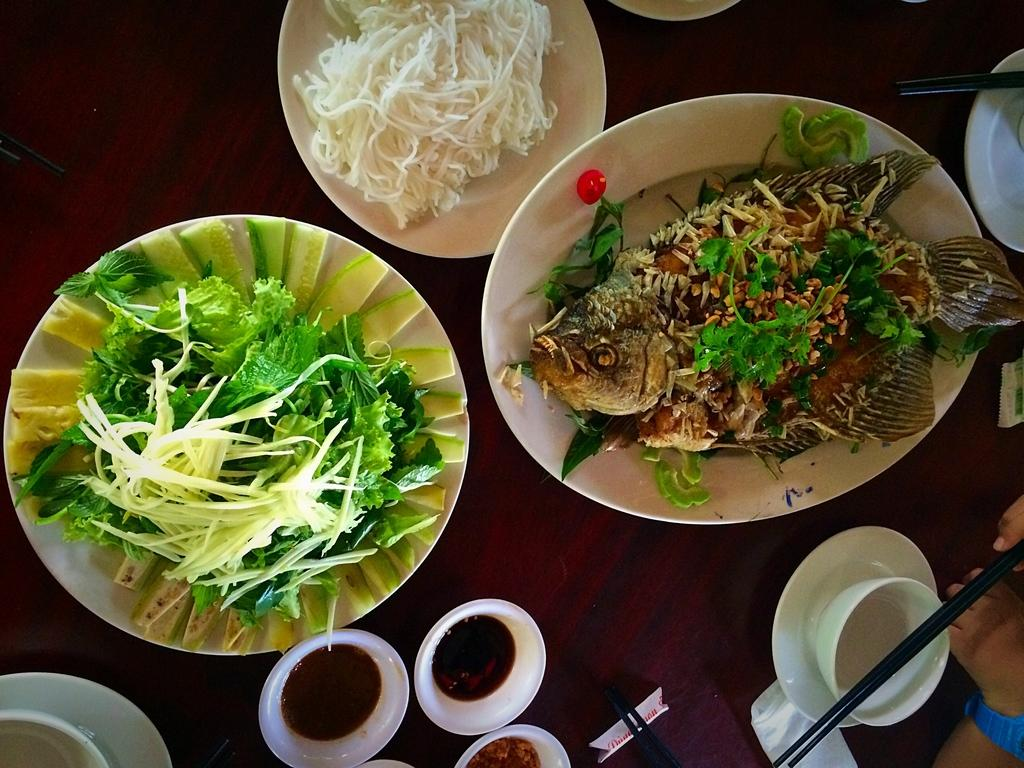What types of tableware are visible in the image? There are plates, bowls, a cup, and a saucer in the image. What type of utensil is present in the image? Chopsticks are present in the image. What types of food can be seen on the plates in the image? There is fish, noodles, and leaves on the plates in the image. What type of vessel is being used to catch fish in the image? There is no vessel or fishing activity depicted in the image; it only shows plates, bowls, a cup, a saucer, chopsticks, and food. 